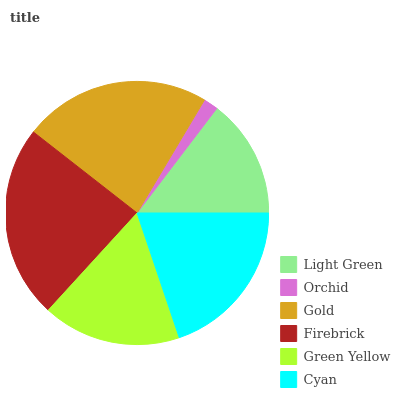Is Orchid the minimum?
Answer yes or no. Yes. Is Firebrick the maximum?
Answer yes or no. Yes. Is Gold the minimum?
Answer yes or no. No. Is Gold the maximum?
Answer yes or no. No. Is Gold greater than Orchid?
Answer yes or no. Yes. Is Orchid less than Gold?
Answer yes or no. Yes. Is Orchid greater than Gold?
Answer yes or no. No. Is Gold less than Orchid?
Answer yes or no. No. Is Cyan the high median?
Answer yes or no. Yes. Is Green Yellow the low median?
Answer yes or no. Yes. Is Gold the high median?
Answer yes or no. No. Is Orchid the low median?
Answer yes or no. No. 